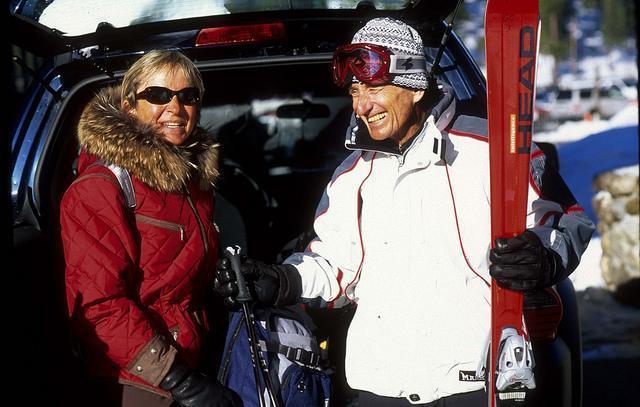How many people are in the photo?
Give a very brief answer. 2. 